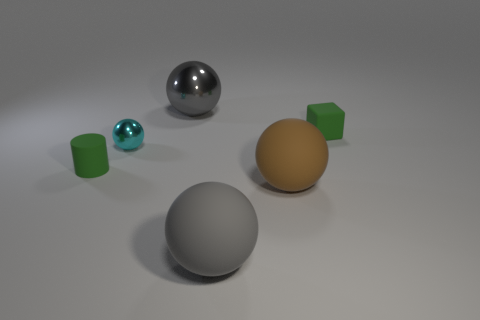Is there a gray shiny sphere of the same size as the cyan object?
Provide a succinct answer. No. What color is the tiny shiny sphere that is behind the green matte thing on the left side of the tiny green cube?
Your answer should be compact. Cyan. How many gray metallic cubes are there?
Your answer should be very brief. 0. Is the color of the rubber block the same as the large metallic thing?
Your answer should be compact. No. Is the number of large gray matte objects to the right of the small cyan sphere less than the number of green cylinders behind the gray metallic object?
Give a very brief answer. No. What color is the tiny metal thing?
Provide a short and direct response. Cyan. What number of rubber balls have the same color as the cylinder?
Provide a succinct answer. 0. There is a tiny green rubber cylinder; are there any gray shiny objects on the left side of it?
Give a very brief answer. No. Is the number of cyan objects on the left side of the green cylinder the same as the number of spheres to the right of the small rubber block?
Your answer should be very brief. Yes. There is a matte object that is behind the small cylinder; does it have the same size as the metallic sphere behind the tiny green cube?
Make the answer very short. No. 